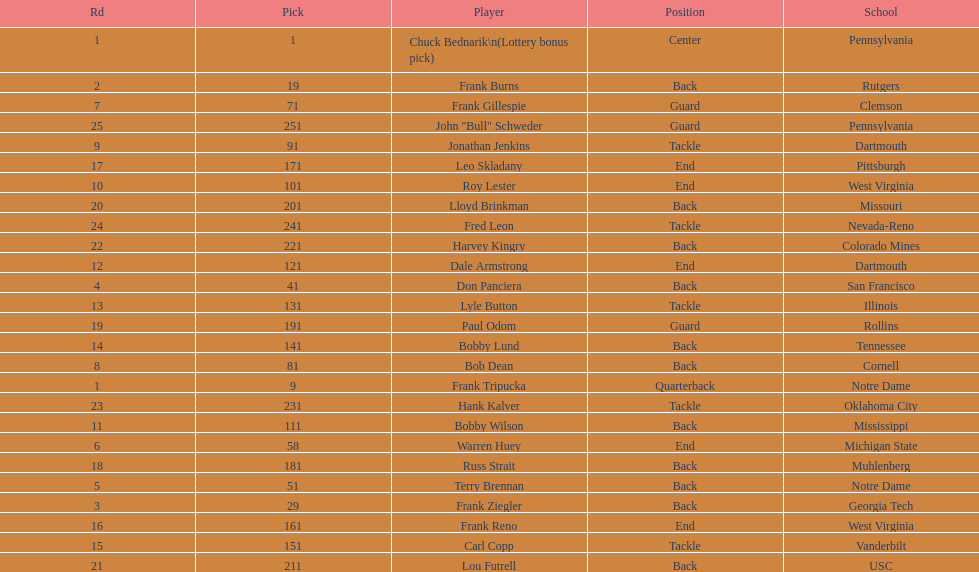Was chuck bednarik or frank tripucka the first draft pick? Chuck Bednarik. 